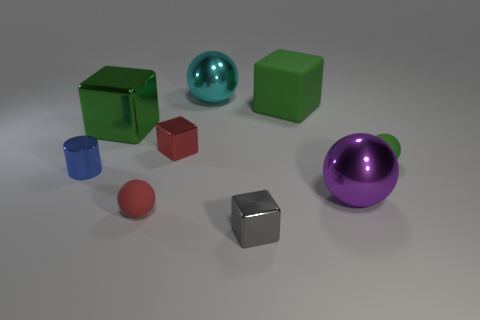Subtract all green blocks. How many blocks are left? 2 Subtract all small gray metallic blocks. How many blocks are left? 3 Subtract 1 green blocks. How many objects are left? 8 Subtract all cylinders. How many objects are left? 8 Subtract 1 cylinders. How many cylinders are left? 0 Subtract all brown cylinders. Subtract all brown cubes. How many cylinders are left? 1 Subtract all brown blocks. How many purple cylinders are left? 0 Subtract all big shiny blocks. Subtract all small metal cylinders. How many objects are left? 7 Add 7 red metallic cubes. How many red metallic cubes are left? 8 Add 5 gray blocks. How many gray blocks exist? 6 